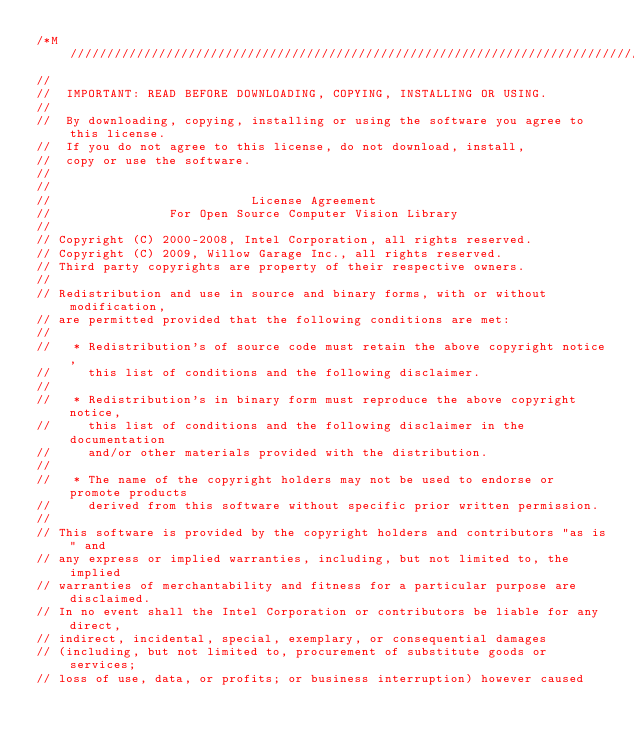Convert code to text. <code><loc_0><loc_0><loc_500><loc_500><_C++_>/*M///////////////////////////////////////////////////////////////////////////////////////
//
//  IMPORTANT: READ BEFORE DOWNLOADING, COPYING, INSTALLING OR USING.
//
//  By downloading, copying, installing or using the software you agree to this license.
//  If you do not agree to this license, do not download, install,
//  copy or use the software.
//
//
//                           License Agreement
//                For Open Source Computer Vision Library
//
// Copyright (C) 2000-2008, Intel Corporation, all rights reserved.
// Copyright (C) 2009, Willow Garage Inc., all rights reserved.
// Third party copyrights are property of their respective owners.
//
// Redistribution and use in source and binary forms, with or without modification,
// are permitted provided that the following conditions are met:
//
//   * Redistribution's of source code must retain the above copyright notice,
//     this list of conditions and the following disclaimer.
//
//   * Redistribution's in binary form must reproduce the above copyright notice,
//     this list of conditions and the following disclaimer in the documentation
//     and/or other materials provided with the distribution.
//
//   * The name of the copyright holders may not be used to endorse or promote products
//     derived from this software without specific prior written permission.
//
// This software is provided by the copyright holders and contributors "as is" and
// any express or implied warranties, including, but not limited to, the implied
// warranties of merchantability and fitness for a particular purpose are disclaimed.
// In no event shall the Intel Corporation or contributors be liable for any direct,
// indirect, incidental, special, exemplary, or consequential damages
// (including, but not limited to, procurement of substitute goods or services;
// loss of use, data, or profits; or business interruption) however caused</code> 